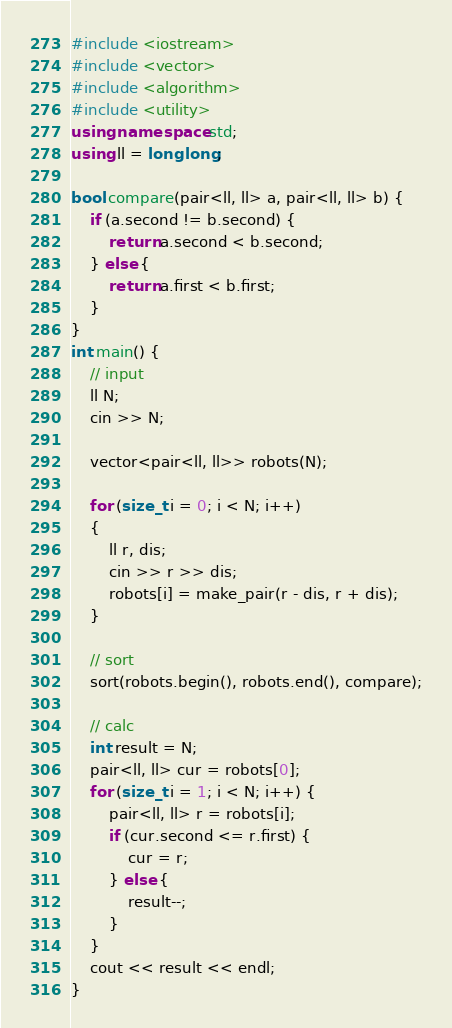Convert code to text. <code><loc_0><loc_0><loc_500><loc_500><_C++_>#include <iostream>
#include <vector>
#include <algorithm>
#include <utility>
using namespace std;
using ll = long long;

bool compare(pair<ll, ll> a, pair<ll, ll> b) {
    if (a.second != b.second) {
        return a.second < b.second;
    } else {
        return a.first < b.first;
    }
}
int main() {
    // input
    ll N;
    cin >> N;

    vector<pair<ll, ll>> robots(N);

    for (size_t i = 0; i < N; i++)
    {
        ll r, dis;
        cin >> r >> dis;
        robots[i] = make_pair(r - dis, r + dis);
    }

    // sort
    sort(robots.begin(), robots.end(), compare);

    // calc
    int result = N;
    pair<ll, ll> cur = robots[0];
    for (size_t i = 1; i < N; i++) {
        pair<ll, ll> r = robots[i];
        if (cur.second <= r.first) {
            cur = r;
        } else {
            result--;
        }
    }
    cout << result << endl;
}</code> 